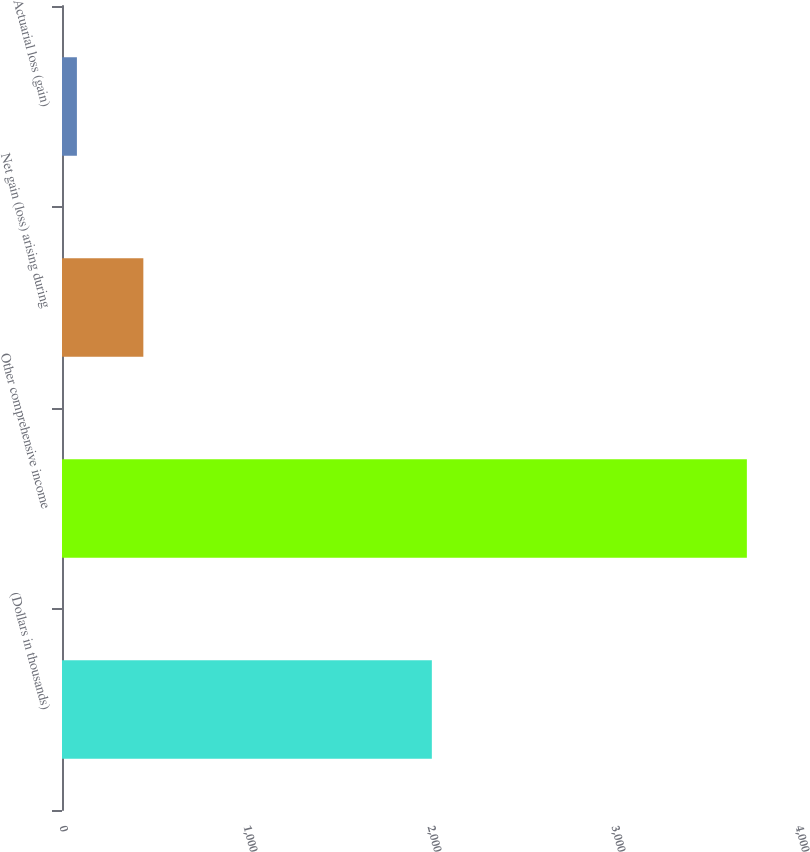Convert chart to OTSL. <chart><loc_0><loc_0><loc_500><loc_500><bar_chart><fcel>(Dollars in thousands)<fcel>Other comprehensive income<fcel>Net gain (loss) arising during<fcel>Actuarial loss (gain)<nl><fcel>2010<fcel>3722.1<fcel>442.1<fcel>81<nl></chart> 